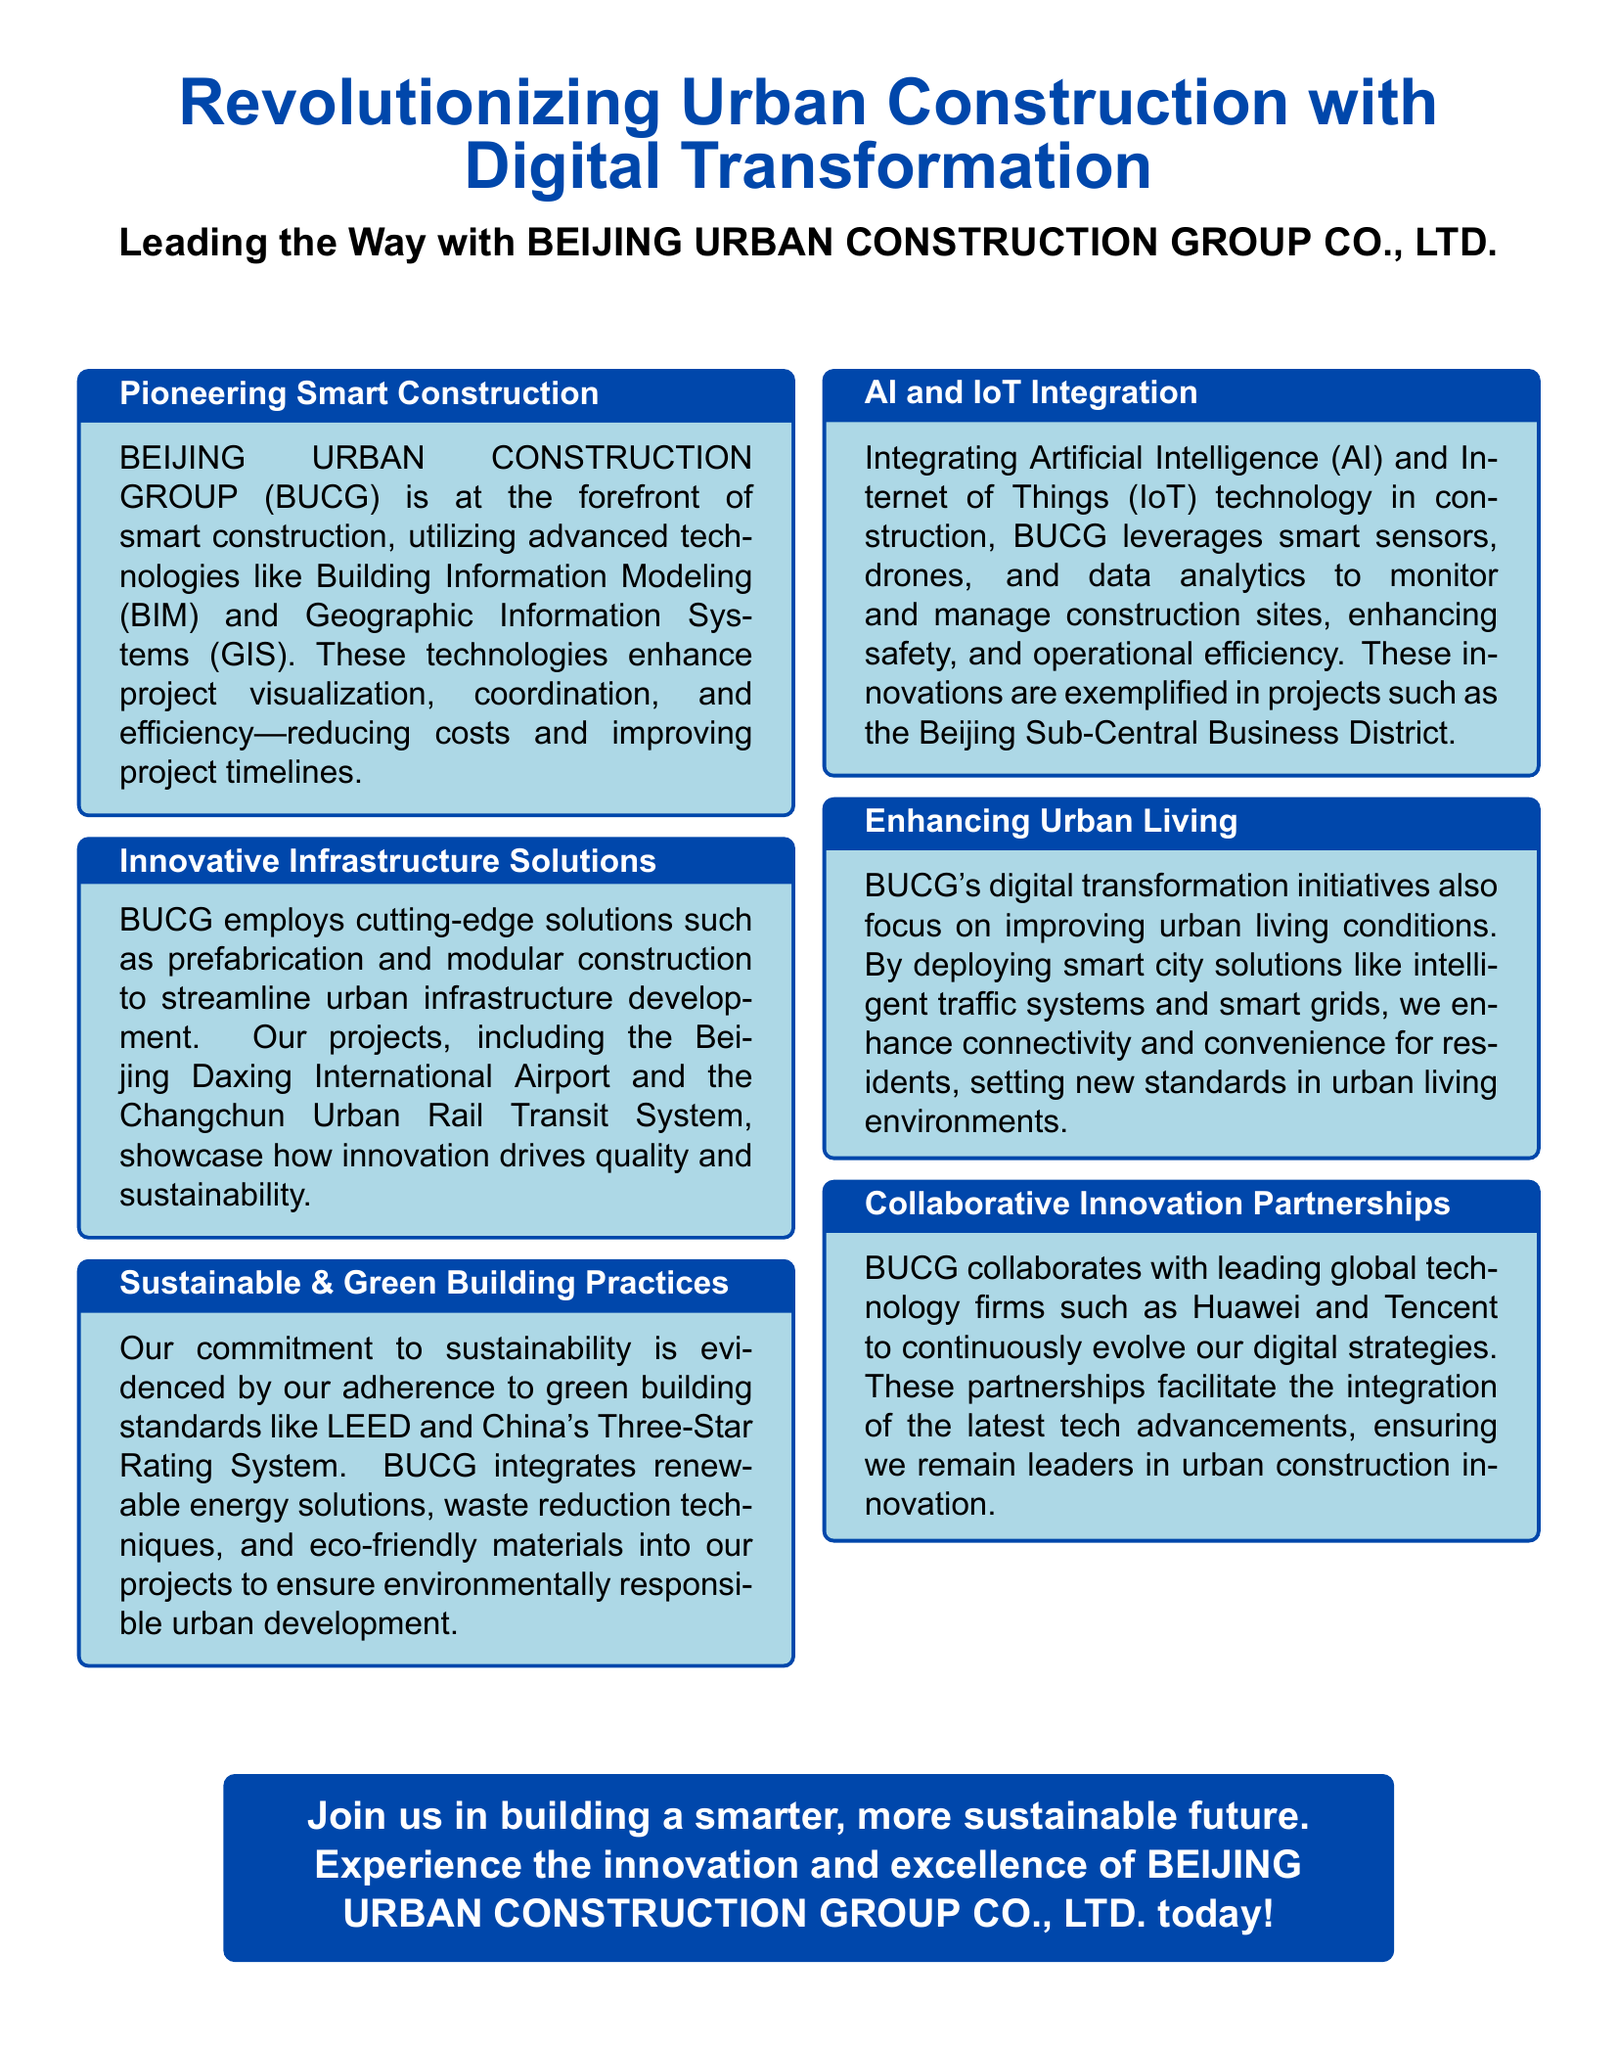What technologies does BUCG utilize for smart construction? The document mentions that BUCG utilizes Building Information Modeling (BIM) and Geographic Information Systems (GIS) for smart construction.
Answer: BIM and GIS What is the name of the airport project mentioned? The advertisement highlights the Beijing Daxing International Airport as one of BUCG's projects showcasing innovation.
Answer: Beijing Daxing International Airport What sustainable building standard does BUCG adhere to? The document states that BUCG adheres to green building standards like LEED and China's Three-Star Rating System.
Answer: LEED and China's Three-Star Rating System What technologies are integrated into BUCG's construction practices? The document lists Artificial Intelligence (AI) and Internet of Things (IoT) as integral technologies in BUCG's construction practices.
Answer: AI and IoT Which company collaborates with BUCG for digital strategies? The document states that BUCG collaborates with leading global technology firms such as Huawei and Tencent to evolve their digital strategies.
Answer: Huawei and Tencent What is the focus of BUCG's digital transformation initiatives? The advertisement emphasizes that BUCG's digital transformation initiatives focus on improving urban living conditions through smart city solutions.
Answer: Improving urban living conditions What benefits do the technologies provide to construction projects? The document explains that the use of advanced technologies enhances project visualization, coordination, efficiency, reduces costs, and improves timelines.
Answer: Reduces costs and improves timelines What urban living enhancements are mentioned in the document? The advertisement highlights the deployment of intelligent traffic systems and smart grids as enhancements to urban living.
Answer: Intelligent traffic systems and smart grids 